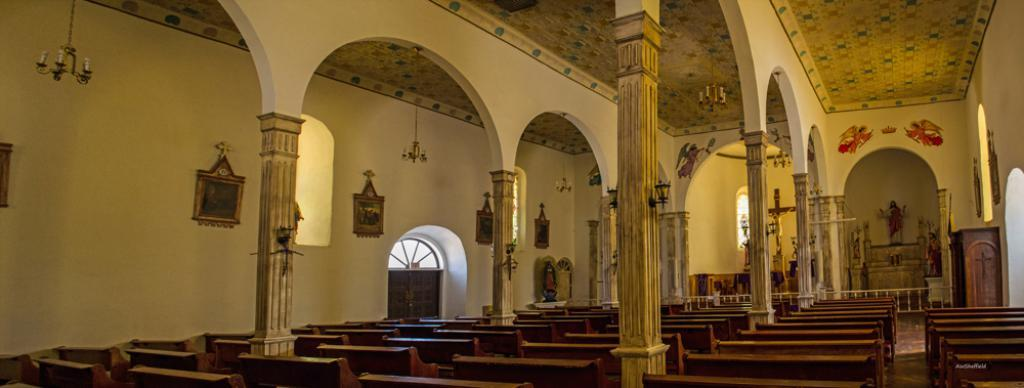What type of location is depicted in the image? The image shows an inner view of a building. What type of furniture is present in the building? There are benches in the building. What architectural elements can be seen in the building? Pillars are present in the building. What type of decorative items are in the building? There are statues in the building. What type of wall decoration is present in the building? The building has stickers on a wall. How can one enter or exit the building? There is a door in the building. What allows natural light to enter the building? Windows are visible in the building. What type of barrier is present in the building? A fence is present in the building. What type of lighting fixture is hanged from the roof in the building? Chandeliers are hanged from the roof in the building. How many oranges are hanging from the chandeliers in the image? There are no oranges present in the image; the chandeliers are not associated with any fruit. 